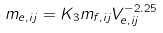Convert formula to latex. <formula><loc_0><loc_0><loc_500><loc_500>m _ { e , i j } = K _ { 3 } m _ { f , i j } V _ { e , i j } ^ { - 2 . 2 5 }</formula> 